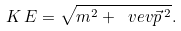Convert formula to latex. <formula><loc_0><loc_0><loc_500><loc_500>K \, E = \sqrt { m ^ { 2 } + \ v e v { \vec { p } \, ^ { 2 } } } .</formula> 